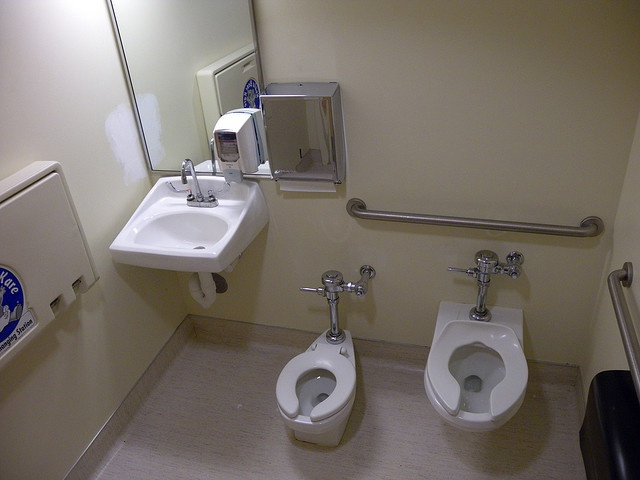Describe the objects in this image and their specific colors. I can see toilet in darkgray, gray, and darkgreen tones, sink in darkgray, lavender, and gray tones, and toilet in darkgray, gray, and black tones in this image. 